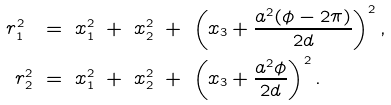Convert formula to latex. <formula><loc_0><loc_0><loc_500><loc_500>r _ { 1 } ^ { 2 } \ & = \ x _ { 1 } ^ { 2 } \ + \ x _ { 2 } ^ { 2 } \ + \ \left ( x _ { 3 } + \frac { a ^ { 2 } ( \phi - 2 \pi ) } { 2 d } \right ) ^ { 2 } , \\ r _ { 2 } ^ { 2 } \ & = \ x _ { 1 } ^ { 2 } \ + \ x _ { 2 } ^ { 2 } \ + \ \left ( x _ { 3 } + \frac { a ^ { 2 } \phi } { 2 d } \right ) ^ { 2 } .</formula> 